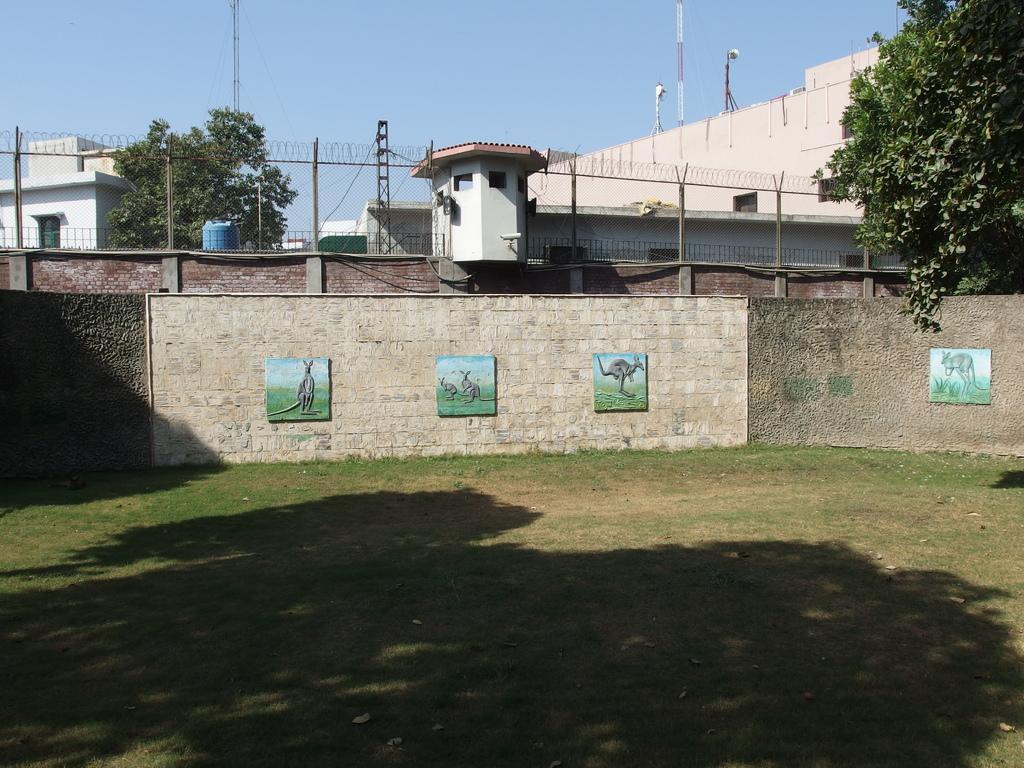Can you describe this image briefly? In this image, we can see trees, buildings, towers, poles along with wires and there are frames placed on the wall. At the bottom, there is ground. 